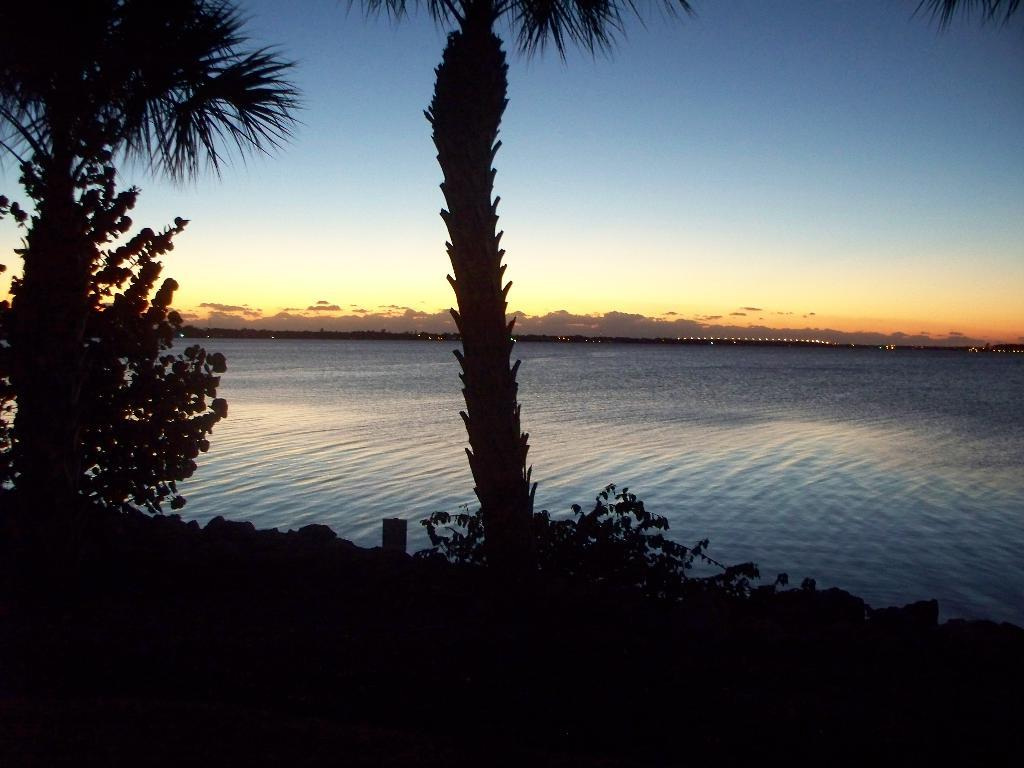What is located in the center of the image? There are trees in the center of the image. What natural element can be seen in the image? There is water visible in the image. What is visible in the background of the image? There is sky visible in the background of the image. What rule is being enforced by the trees in the image? There is no rule being enforced by the trees in the image; they are simply trees in a natural setting. 